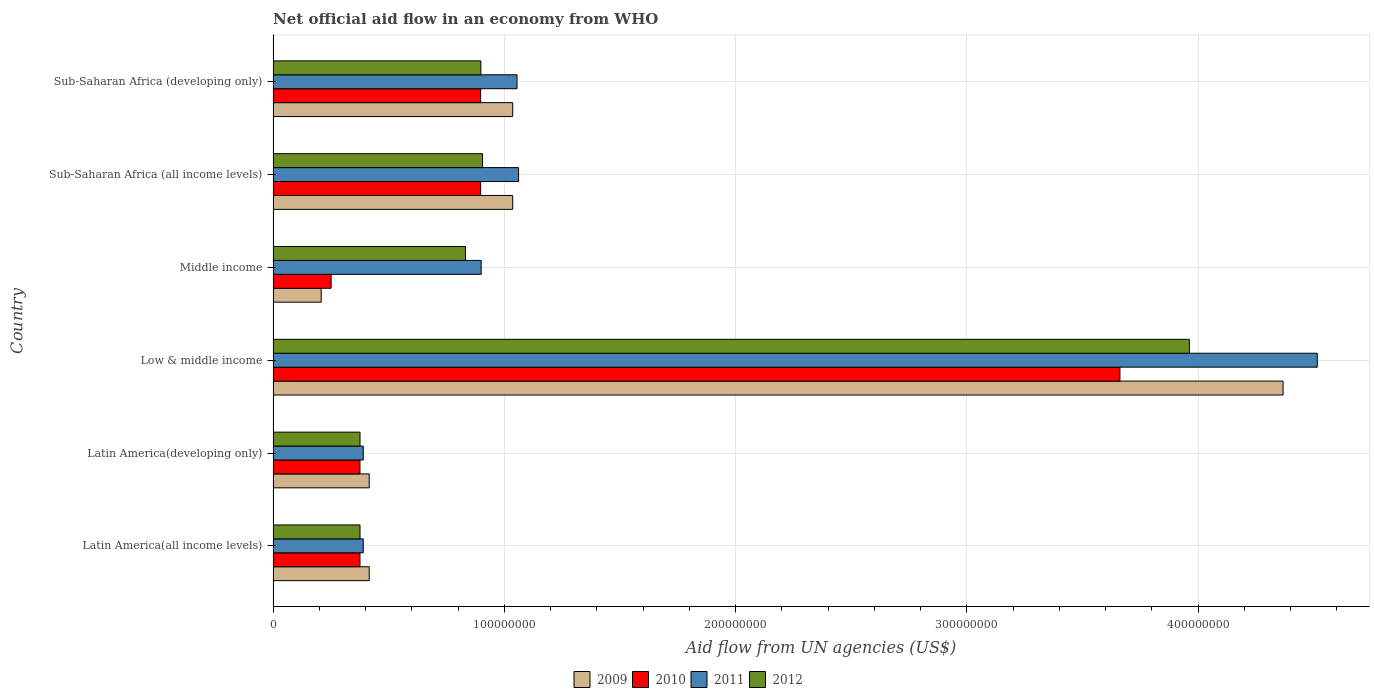How many different coloured bars are there?
Provide a succinct answer. 4. How many groups of bars are there?
Provide a succinct answer. 6. Are the number of bars per tick equal to the number of legend labels?
Provide a succinct answer. Yes. Are the number of bars on each tick of the Y-axis equal?
Provide a short and direct response. Yes. How many bars are there on the 5th tick from the top?
Ensure brevity in your answer.  4. What is the label of the 1st group of bars from the top?
Provide a short and direct response. Sub-Saharan Africa (developing only). In how many cases, is the number of bars for a given country not equal to the number of legend labels?
Your answer should be very brief. 0. What is the net official aid flow in 2010 in Middle income?
Keep it short and to the point. 2.51e+07. Across all countries, what is the maximum net official aid flow in 2011?
Your response must be concise. 4.52e+08. Across all countries, what is the minimum net official aid flow in 2011?
Ensure brevity in your answer.  3.90e+07. In which country was the net official aid flow in 2011 maximum?
Your answer should be very brief. Low & middle income. In which country was the net official aid flow in 2012 minimum?
Keep it short and to the point. Latin America(all income levels). What is the total net official aid flow in 2012 in the graph?
Give a very brief answer. 7.35e+08. What is the difference between the net official aid flow in 2012 in Middle income and that in Sub-Saharan Africa (developing only)?
Ensure brevity in your answer.  -6.67e+06. What is the difference between the net official aid flow in 2009 in Sub-Saharan Africa (all income levels) and the net official aid flow in 2011 in Low & middle income?
Your answer should be very brief. -3.48e+08. What is the average net official aid flow in 2009 per country?
Your answer should be very brief. 1.25e+08. What is the difference between the net official aid flow in 2011 and net official aid flow in 2010 in Latin America(all income levels)?
Give a very brief answer. 1.42e+06. In how many countries, is the net official aid flow in 2011 greater than 380000000 US$?
Ensure brevity in your answer.  1. What is the ratio of the net official aid flow in 2010 in Middle income to that in Sub-Saharan Africa (developing only)?
Your answer should be compact. 0.28. Is the net official aid flow in 2011 in Latin America(developing only) less than that in Sub-Saharan Africa (developing only)?
Your answer should be compact. Yes. What is the difference between the highest and the second highest net official aid flow in 2012?
Keep it short and to the point. 3.06e+08. What is the difference between the highest and the lowest net official aid flow in 2012?
Ensure brevity in your answer.  3.59e+08. In how many countries, is the net official aid flow in 2012 greater than the average net official aid flow in 2012 taken over all countries?
Provide a short and direct response. 1. Is the sum of the net official aid flow in 2010 in Low & middle income and Sub-Saharan Africa (developing only) greater than the maximum net official aid flow in 2012 across all countries?
Ensure brevity in your answer.  Yes. Is it the case that in every country, the sum of the net official aid flow in 2010 and net official aid flow in 2009 is greater than the sum of net official aid flow in 2011 and net official aid flow in 2012?
Offer a terse response. No. How many bars are there?
Your response must be concise. 24. Are all the bars in the graph horizontal?
Offer a terse response. Yes. How many countries are there in the graph?
Give a very brief answer. 6. Does the graph contain any zero values?
Give a very brief answer. No. Does the graph contain grids?
Your answer should be very brief. Yes. Where does the legend appear in the graph?
Offer a very short reply. Bottom center. How many legend labels are there?
Ensure brevity in your answer.  4. What is the title of the graph?
Your answer should be compact. Net official aid flow in an economy from WHO. Does "1962" appear as one of the legend labels in the graph?
Offer a very short reply. No. What is the label or title of the X-axis?
Your answer should be compact. Aid flow from UN agencies (US$). What is the label or title of the Y-axis?
Provide a succinct answer. Country. What is the Aid flow from UN agencies (US$) in 2009 in Latin America(all income levels)?
Give a very brief answer. 4.16e+07. What is the Aid flow from UN agencies (US$) in 2010 in Latin America(all income levels)?
Offer a terse response. 3.76e+07. What is the Aid flow from UN agencies (US$) in 2011 in Latin America(all income levels)?
Offer a very short reply. 3.90e+07. What is the Aid flow from UN agencies (US$) of 2012 in Latin America(all income levels)?
Your answer should be very brief. 3.76e+07. What is the Aid flow from UN agencies (US$) in 2009 in Latin America(developing only)?
Your answer should be very brief. 4.16e+07. What is the Aid flow from UN agencies (US$) of 2010 in Latin America(developing only)?
Offer a terse response. 3.76e+07. What is the Aid flow from UN agencies (US$) in 2011 in Latin America(developing only)?
Offer a terse response. 3.90e+07. What is the Aid flow from UN agencies (US$) in 2012 in Latin America(developing only)?
Keep it short and to the point. 3.76e+07. What is the Aid flow from UN agencies (US$) of 2009 in Low & middle income?
Offer a terse response. 4.37e+08. What is the Aid flow from UN agencies (US$) of 2010 in Low & middle income?
Provide a short and direct response. 3.66e+08. What is the Aid flow from UN agencies (US$) in 2011 in Low & middle income?
Give a very brief answer. 4.52e+08. What is the Aid flow from UN agencies (US$) in 2012 in Low & middle income?
Provide a succinct answer. 3.96e+08. What is the Aid flow from UN agencies (US$) of 2009 in Middle income?
Provide a succinct answer. 2.08e+07. What is the Aid flow from UN agencies (US$) of 2010 in Middle income?
Provide a succinct answer. 2.51e+07. What is the Aid flow from UN agencies (US$) in 2011 in Middle income?
Your answer should be very brief. 9.00e+07. What is the Aid flow from UN agencies (US$) in 2012 in Middle income?
Keep it short and to the point. 8.32e+07. What is the Aid flow from UN agencies (US$) of 2009 in Sub-Saharan Africa (all income levels)?
Offer a terse response. 1.04e+08. What is the Aid flow from UN agencies (US$) of 2010 in Sub-Saharan Africa (all income levels)?
Your response must be concise. 8.98e+07. What is the Aid flow from UN agencies (US$) in 2011 in Sub-Saharan Africa (all income levels)?
Give a very brief answer. 1.06e+08. What is the Aid flow from UN agencies (US$) of 2012 in Sub-Saharan Africa (all income levels)?
Give a very brief answer. 9.06e+07. What is the Aid flow from UN agencies (US$) of 2009 in Sub-Saharan Africa (developing only)?
Provide a succinct answer. 1.04e+08. What is the Aid flow from UN agencies (US$) in 2010 in Sub-Saharan Africa (developing only)?
Your answer should be compact. 8.98e+07. What is the Aid flow from UN agencies (US$) in 2011 in Sub-Saharan Africa (developing only)?
Ensure brevity in your answer.  1.05e+08. What is the Aid flow from UN agencies (US$) of 2012 in Sub-Saharan Africa (developing only)?
Your response must be concise. 8.98e+07. Across all countries, what is the maximum Aid flow from UN agencies (US$) of 2009?
Ensure brevity in your answer.  4.37e+08. Across all countries, what is the maximum Aid flow from UN agencies (US$) of 2010?
Give a very brief answer. 3.66e+08. Across all countries, what is the maximum Aid flow from UN agencies (US$) in 2011?
Ensure brevity in your answer.  4.52e+08. Across all countries, what is the maximum Aid flow from UN agencies (US$) in 2012?
Make the answer very short. 3.96e+08. Across all countries, what is the minimum Aid flow from UN agencies (US$) in 2009?
Offer a terse response. 2.08e+07. Across all countries, what is the minimum Aid flow from UN agencies (US$) in 2010?
Give a very brief answer. 2.51e+07. Across all countries, what is the minimum Aid flow from UN agencies (US$) of 2011?
Your response must be concise. 3.90e+07. Across all countries, what is the minimum Aid flow from UN agencies (US$) of 2012?
Make the answer very short. 3.76e+07. What is the total Aid flow from UN agencies (US$) of 2009 in the graph?
Give a very brief answer. 7.48e+08. What is the total Aid flow from UN agencies (US$) of 2010 in the graph?
Provide a succinct answer. 6.46e+08. What is the total Aid flow from UN agencies (US$) of 2011 in the graph?
Ensure brevity in your answer.  8.31e+08. What is the total Aid flow from UN agencies (US$) in 2012 in the graph?
Give a very brief answer. 7.35e+08. What is the difference between the Aid flow from UN agencies (US$) in 2010 in Latin America(all income levels) and that in Latin America(developing only)?
Make the answer very short. 0. What is the difference between the Aid flow from UN agencies (US$) of 2012 in Latin America(all income levels) and that in Latin America(developing only)?
Provide a short and direct response. 0. What is the difference between the Aid flow from UN agencies (US$) of 2009 in Latin America(all income levels) and that in Low & middle income?
Offer a terse response. -3.95e+08. What is the difference between the Aid flow from UN agencies (US$) in 2010 in Latin America(all income levels) and that in Low & middle income?
Offer a very short reply. -3.29e+08. What is the difference between the Aid flow from UN agencies (US$) of 2011 in Latin America(all income levels) and that in Low & middle income?
Your answer should be compact. -4.13e+08. What is the difference between the Aid flow from UN agencies (US$) of 2012 in Latin America(all income levels) and that in Low & middle income?
Offer a very short reply. -3.59e+08. What is the difference between the Aid flow from UN agencies (US$) of 2009 in Latin America(all income levels) and that in Middle income?
Offer a terse response. 2.08e+07. What is the difference between the Aid flow from UN agencies (US$) of 2010 in Latin America(all income levels) and that in Middle income?
Your answer should be very brief. 1.25e+07. What is the difference between the Aid flow from UN agencies (US$) in 2011 in Latin America(all income levels) and that in Middle income?
Your answer should be very brief. -5.10e+07. What is the difference between the Aid flow from UN agencies (US$) in 2012 in Latin America(all income levels) and that in Middle income?
Your response must be concise. -4.56e+07. What is the difference between the Aid flow from UN agencies (US$) in 2009 in Latin America(all income levels) and that in Sub-Saharan Africa (all income levels)?
Your answer should be very brief. -6.20e+07. What is the difference between the Aid flow from UN agencies (US$) in 2010 in Latin America(all income levels) and that in Sub-Saharan Africa (all income levels)?
Your response must be concise. -5.22e+07. What is the difference between the Aid flow from UN agencies (US$) in 2011 in Latin America(all income levels) and that in Sub-Saharan Africa (all income levels)?
Ensure brevity in your answer.  -6.72e+07. What is the difference between the Aid flow from UN agencies (US$) of 2012 in Latin America(all income levels) and that in Sub-Saharan Africa (all income levels)?
Offer a terse response. -5.30e+07. What is the difference between the Aid flow from UN agencies (US$) of 2009 in Latin America(all income levels) and that in Sub-Saharan Africa (developing only)?
Provide a succinct answer. -6.20e+07. What is the difference between the Aid flow from UN agencies (US$) of 2010 in Latin America(all income levels) and that in Sub-Saharan Africa (developing only)?
Your answer should be very brief. -5.22e+07. What is the difference between the Aid flow from UN agencies (US$) in 2011 in Latin America(all income levels) and that in Sub-Saharan Africa (developing only)?
Offer a terse response. -6.65e+07. What is the difference between the Aid flow from UN agencies (US$) in 2012 in Latin America(all income levels) and that in Sub-Saharan Africa (developing only)?
Provide a short and direct response. -5.23e+07. What is the difference between the Aid flow from UN agencies (US$) in 2009 in Latin America(developing only) and that in Low & middle income?
Ensure brevity in your answer.  -3.95e+08. What is the difference between the Aid flow from UN agencies (US$) of 2010 in Latin America(developing only) and that in Low & middle income?
Give a very brief answer. -3.29e+08. What is the difference between the Aid flow from UN agencies (US$) in 2011 in Latin America(developing only) and that in Low & middle income?
Your answer should be very brief. -4.13e+08. What is the difference between the Aid flow from UN agencies (US$) in 2012 in Latin America(developing only) and that in Low & middle income?
Keep it short and to the point. -3.59e+08. What is the difference between the Aid flow from UN agencies (US$) of 2009 in Latin America(developing only) and that in Middle income?
Offer a terse response. 2.08e+07. What is the difference between the Aid flow from UN agencies (US$) in 2010 in Latin America(developing only) and that in Middle income?
Your answer should be compact. 1.25e+07. What is the difference between the Aid flow from UN agencies (US$) of 2011 in Latin America(developing only) and that in Middle income?
Ensure brevity in your answer.  -5.10e+07. What is the difference between the Aid flow from UN agencies (US$) in 2012 in Latin America(developing only) and that in Middle income?
Your answer should be very brief. -4.56e+07. What is the difference between the Aid flow from UN agencies (US$) in 2009 in Latin America(developing only) and that in Sub-Saharan Africa (all income levels)?
Provide a succinct answer. -6.20e+07. What is the difference between the Aid flow from UN agencies (US$) of 2010 in Latin America(developing only) and that in Sub-Saharan Africa (all income levels)?
Provide a short and direct response. -5.22e+07. What is the difference between the Aid flow from UN agencies (US$) of 2011 in Latin America(developing only) and that in Sub-Saharan Africa (all income levels)?
Your response must be concise. -6.72e+07. What is the difference between the Aid flow from UN agencies (US$) in 2012 in Latin America(developing only) and that in Sub-Saharan Africa (all income levels)?
Your answer should be very brief. -5.30e+07. What is the difference between the Aid flow from UN agencies (US$) in 2009 in Latin America(developing only) and that in Sub-Saharan Africa (developing only)?
Offer a very short reply. -6.20e+07. What is the difference between the Aid flow from UN agencies (US$) in 2010 in Latin America(developing only) and that in Sub-Saharan Africa (developing only)?
Make the answer very short. -5.22e+07. What is the difference between the Aid flow from UN agencies (US$) of 2011 in Latin America(developing only) and that in Sub-Saharan Africa (developing only)?
Provide a short and direct response. -6.65e+07. What is the difference between the Aid flow from UN agencies (US$) of 2012 in Latin America(developing only) and that in Sub-Saharan Africa (developing only)?
Your response must be concise. -5.23e+07. What is the difference between the Aid flow from UN agencies (US$) of 2009 in Low & middle income and that in Middle income?
Offer a very short reply. 4.16e+08. What is the difference between the Aid flow from UN agencies (US$) of 2010 in Low & middle income and that in Middle income?
Keep it short and to the point. 3.41e+08. What is the difference between the Aid flow from UN agencies (US$) in 2011 in Low & middle income and that in Middle income?
Ensure brevity in your answer.  3.62e+08. What is the difference between the Aid flow from UN agencies (US$) of 2012 in Low & middle income and that in Middle income?
Your answer should be compact. 3.13e+08. What is the difference between the Aid flow from UN agencies (US$) in 2009 in Low & middle income and that in Sub-Saharan Africa (all income levels)?
Provide a short and direct response. 3.33e+08. What is the difference between the Aid flow from UN agencies (US$) of 2010 in Low & middle income and that in Sub-Saharan Africa (all income levels)?
Offer a terse response. 2.76e+08. What is the difference between the Aid flow from UN agencies (US$) of 2011 in Low & middle income and that in Sub-Saharan Africa (all income levels)?
Offer a very short reply. 3.45e+08. What is the difference between the Aid flow from UN agencies (US$) of 2012 in Low & middle income and that in Sub-Saharan Africa (all income levels)?
Provide a succinct answer. 3.06e+08. What is the difference between the Aid flow from UN agencies (US$) of 2009 in Low & middle income and that in Sub-Saharan Africa (developing only)?
Keep it short and to the point. 3.33e+08. What is the difference between the Aid flow from UN agencies (US$) of 2010 in Low & middle income and that in Sub-Saharan Africa (developing only)?
Your answer should be compact. 2.76e+08. What is the difference between the Aid flow from UN agencies (US$) in 2011 in Low & middle income and that in Sub-Saharan Africa (developing only)?
Provide a succinct answer. 3.46e+08. What is the difference between the Aid flow from UN agencies (US$) in 2012 in Low & middle income and that in Sub-Saharan Africa (developing only)?
Your answer should be very brief. 3.06e+08. What is the difference between the Aid flow from UN agencies (US$) in 2009 in Middle income and that in Sub-Saharan Africa (all income levels)?
Your response must be concise. -8.28e+07. What is the difference between the Aid flow from UN agencies (US$) of 2010 in Middle income and that in Sub-Saharan Africa (all income levels)?
Offer a terse response. -6.47e+07. What is the difference between the Aid flow from UN agencies (US$) in 2011 in Middle income and that in Sub-Saharan Africa (all income levels)?
Keep it short and to the point. -1.62e+07. What is the difference between the Aid flow from UN agencies (US$) of 2012 in Middle income and that in Sub-Saharan Africa (all income levels)?
Your response must be concise. -7.39e+06. What is the difference between the Aid flow from UN agencies (US$) of 2009 in Middle income and that in Sub-Saharan Africa (developing only)?
Your answer should be very brief. -8.28e+07. What is the difference between the Aid flow from UN agencies (US$) of 2010 in Middle income and that in Sub-Saharan Africa (developing only)?
Ensure brevity in your answer.  -6.47e+07. What is the difference between the Aid flow from UN agencies (US$) in 2011 in Middle income and that in Sub-Saharan Africa (developing only)?
Offer a very short reply. -1.55e+07. What is the difference between the Aid flow from UN agencies (US$) in 2012 in Middle income and that in Sub-Saharan Africa (developing only)?
Make the answer very short. -6.67e+06. What is the difference between the Aid flow from UN agencies (US$) in 2011 in Sub-Saharan Africa (all income levels) and that in Sub-Saharan Africa (developing only)?
Offer a terse response. 6.70e+05. What is the difference between the Aid flow from UN agencies (US$) of 2012 in Sub-Saharan Africa (all income levels) and that in Sub-Saharan Africa (developing only)?
Your answer should be compact. 7.20e+05. What is the difference between the Aid flow from UN agencies (US$) of 2009 in Latin America(all income levels) and the Aid flow from UN agencies (US$) of 2010 in Latin America(developing only)?
Offer a very short reply. 4.01e+06. What is the difference between the Aid flow from UN agencies (US$) of 2009 in Latin America(all income levels) and the Aid flow from UN agencies (US$) of 2011 in Latin America(developing only)?
Provide a short and direct response. 2.59e+06. What is the difference between the Aid flow from UN agencies (US$) in 2009 in Latin America(all income levels) and the Aid flow from UN agencies (US$) in 2012 in Latin America(developing only)?
Provide a short and direct response. 3.99e+06. What is the difference between the Aid flow from UN agencies (US$) of 2010 in Latin America(all income levels) and the Aid flow from UN agencies (US$) of 2011 in Latin America(developing only)?
Give a very brief answer. -1.42e+06. What is the difference between the Aid flow from UN agencies (US$) of 2010 in Latin America(all income levels) and the Aid flow from UN agencies (US$) of 2012 in Latin America(developing only)?
Your response must be concise. -2.00e+04. What is the difference between the Aid flow from UN agencies (US$) of 2011 in Latin America(all income levels) and the Aid flow from UN agencies (US$) of 2012 in Latin America(developing only)?
Ensure brevity in your answer.  1.40e+06. What is the difference between the Aid flow from UN agencies (US$) of 2009 in Latin America(all income levels) and the Aid flow from UN agencies (US$) of 2010 in Low & middle income?
Provide a succinct answer. -3.25e+08. What is the difference between the Aid flow from UN agencies (US$) in 2009 in Latin America(all income levels) and the Aid flow from UN agencies (US$) in 2011 in Low & middle income?
Ensure brevity in your answer.  -4.10e+08. What is the difference between the Aid flow from UN agencies (US$) in 2009 in Latin America(all income levels) and the Aid flow from UN agencies (US$) in 2012 in Low & middle income?
Your answer should be compact. -3.55e+08. What is the difference between the Aid flow from UN agencies (US$) of 2010 in Latin America(all income levels) and the Aid flow from UN agencies (US$) of 2011 in Low & middle income?
Your answer should be compact. -4.14e+08. What is the difference between the Aid flow from UN agencies (US$) of 2010 in Latin America(all income levels) and the Aid flow from UN agencies (US$) of 2012 in Low & middle income?
Provide a short and direct response. -3.59e+08. What is the difference between the Aid flow from UN agencies (US$) in 2011 in Latin America(all income levels) and the Aid flow from UN agencies (US$) in 2012 in Low & middle income?
Provide a short and direct response. -3.57e+08. What is the difference between the Aid flow from UN agencies (US$) in 2009 in Latin America(all income levels) and the Aid flow from UN agencies (US$) in 2010 in Middle income?
Ensure brevity in your answer.  1.65e+07. What is the difference between the Aid flow from UN agencies (US$) in 2009 in Latin America(all income levels) and the Aid flow from UN agencies (US$) in 2011 in Middle income?
Your response must be concise. -4.84e+07. What is the difference between the Aid flow from UN agencies (US$) of 2009 in Latin America(all income levels) and the Aid flow from UN agencies (US$) of 2012 in Middle income?
Provide a succinct answer. -4.16e+07. What is the difference between the Aid flow from UN agencies (US$) of 2010 in Latin America(all income levels) and the Aid flow from UN agencies (US$) of 2011 in Middle income?
Keep it short and to the point. -5.24e+07. What is the difference between the Aid flow from UN agencies (US$) in 2010 in Latin America(all income levels) and the Aid flow from UN agencies (US$) in 2012 in Middle income?
Keep it short and to the point. -4.56e+07. What is the difference between the Aid flow from UN agencies (US$) in 2011 in Latin America(all income levels) and the Aid flow from UN agencies (US$) in 2012 in Middle income?
Provide a succinct answer. -4.42e+07. What is the difference between the Aid flow from UN agencies (US$) of 2009 in Latin America(all income levels) and the Aid flow from UN agencies (US$) of 2010 in Sub-Saharan Africa (all income levels)?
Offer a terse response. -4.82e+07. What is the difference between the Aid flow from UN agencies (US$) in 2009 in Latin America(all income levels) and the Aid flow from UN agencies (US$) in 2011 in Sub-Saharan Africa (all income levels)?
Your response must be concise. -6.46e+07. What is the difference between the Aid flow from UN agencies (US$) in 2009 in Latin America(all income levels) and the Aid flow from UN agencies (US$) in 2012 in Sub-Saharan Africa (all income levels)?
Offer a very short reply. -4.90e+07. What is the difference between the Aid flow from UN agencies (US$) in 2010 in Latin America(all income levels) and the Aid flow from UN agencies (US$) in 2011 in Sub-Saharan Africa (all income levels)?
Ensure brevity in your answer.  -6.86e+07. What is the difference between the Aid flow from UN agencies (US$) of 2010 in Latin America(all income levels) and the Aid flow from UN agencies (US$) of 2012 in Sub-Saharan Africa (all income levels)?
Offer a terse response. -5.30e+07. What is the difference between the Aid flow from UN agencies (US$) of 2011 in Latin America(all income levels) and the Aid flow from UN agencies (US$) of 2012 in Sub-Saharan Africa (all income levels)?
Provide a short and direct response. -5.16e+07. What is the difference between the Aid flow from UN agencies (US$) of 2009 in Latin America(all income levels) and the Aid flow from UN agencies (US$) of 2010 in Sub-Saharan Africa (developing only)?
Provide a succinct answer. -4.82e+07. What is the difference between the Aid flow from UN agencies (US$) in 2009 in Latin America(all income levels) and the Aid flow from UN agencies (US$) in 2011 in Sub-Saharan Africa (developing only)?
Ensure brevity in your answer.  -6.39e+07. What is the difference between the Aid flow from UN agencies (US$) in 2009 in Latin America(all income levels) and the Aid flow from UN agencies (US$) in 2012 in Sub-Saharan Africa (developing only)?
Offer a terse response. -4.83e+07. What is the difference between the Aid flow from UN agencies (US$) in 2010 in Latin America(all income levels) and the Aid flow from UN agencies (US$) in 2011 in Sub-Saharan Africa (developing only)?
Provide a succinct answer. -6.79e+07. What is the difference between the Aid flow from UN agencies (US$) in 2010 in Latin America(all income levels) and the Aid flow from UN agencies (US$) in 2012 in Sub-Saharan Africa (developing only)?
Give a very brief answer. -5.23e+07. What is the difference between the Aid flow from UN agencies (US$) in 2011 in Latin America(all income levels) and the Aid flow from UN agencies (US$) in 2012 in Sub-Saharan Africa (developing only)?
Offer a very short reply. -5.09e+07. What is the difference between the Aid flow from UN agencies (US$) of 2009 in Latin America(developing only) and the Aid flow from UN agencies (US$) of 2010 in Low & middle income?
Your answer should be very brief. -3.25e+08. What is the difference between the Aid flow from UN agencies (US$) in 2009 in Latin America(developing only) and the Aid flow from UN agencies (US$) in 2011 in Low & middle income?
Give a very brief answer. -4.10e+08. What is the difference between the Aid flow from UN agencies (US$) of 2009 in Latin America(developing only) and the Aid flow from UN agencies (US$) of 2012 in Low & middle income?
Provide a succinct answer. -3.55e+08. What is the difference between the Aid flow from UN agencies (US$) in 2010 in Latin America(developing only) and the Aid flow from UN agencies (US$) in 2011 in Low & middle income?
Offer a very short reply. -4.14e+08. What is the difference between the Aid flow from UN agencies (US$) in 2010 in Latin America(developing only) and the Aid flow from UN agencies (US$) in 2012 in Low & middle income?
Provide a succinct answer. -3.59e+08. What is the difference between the Aid flow from UN agencies (US$) of 2011 in Latin America(developing only) and the Aid flow from UN agencies (US$) of 2012 in Low & middle income?
Make the answer very short. -3.57e+08. What is the difference between the Aid flow from UN agencies (US$) in 2009 in Latin America(developing only) and the Aid flow from UN agencies (US$) in 2010 in Middle income?
Make the answer very short. 1.65e+07. What is the difference between the Aid flow from UN agencies (US$) of 2009 in Latin America(developing only) and the Aid flow from UN agencies (US$) of 2011 in Middle income?
Provide a succinct answer. -4.84e+07. What is the difference between the Aid flow from UN agencies (US$) in 2009 in Latin America(developing only) and the Aid flow from UN agencies (US$) in 2012 in Middle income?
Give a very brief answer. -4.16e+07. What is the difference between the Aid flow from UN agencies (US$) of 2010 in Latin America(developing only) and the Aid flow from UN agencies (US$) of 2011 in Middle income?
Your answer should be compact. -5.24e+07. What is the difference between the Aid flow from UN agencies (US$) in 2010 in Latin America(developing only) and the Aid flow from UN agencies (US$) in 2012 in Middle income?
Provide a short and direct response. -4.56e+07. What is the difference between the Aid flow from UN agencies (US$) of 2011 in Latin America(developing only) and the Aid flow from UN agencies (US$) of 2012 in Middle income?
Offer a terse response. -4.42e+07. What is the difference between the Aid flow from UN agencies (US$) in 2009 in Latin America(developing only) and the Aid flow from UN agencies (US$) in 2010 in Sub-Saharan Africa (all income levels)?
Make the answer very short. -4.82e+07. What is the difference between the Aid flow from UN agencies (US$) of 2009 in Latin America(developing only) and the Aid flow from UN agencies (US$) of 2011 in Sub-Saharan Africa (all income levels)?
Give a very brief answer. -6.46e+07. What is the difference between the Aid flow from UN agencies (US$) of 2009 in Latin America(developing only) and the Aid flow from UN agencies (US$) of 2012 in Sub-Saharan Africa (all income levels)?
Provide a short and direct response. -4.90e+07. What is the difference between the Aid flow from UN agencies (US$) of 2010 in Latin America(developing only) and the Aid flow from UN agencies (US$) of 2011 in Sub-Saharan Africa (all income levels)?
Offer a terse response. -6.86e+07. What is the difference between the Aid flow from UN agencies (US$) of 2010 in Latin America(developing only) and the Aid flow from UN agencies (US$) of 2012 in Sub-Saharan Africa (all income levels)?
Give a very brief answer. -5.30e+07. What is the difference between the Aid flow from UN agencies (US$) in 2011 in Latin America(developing only) and the Aid flow from UN agencies (US$) in 2012 in Sub-Saharan Africa (all income levels)?
Provide a short and direct response. -5.16e+07. What is the difference between the Aid flow from UN agencies (US$) of 2009 in Latin America(developing only) and the Aid flow from UN agencies (US$) of 2010 in Sub-Saharan Africa (developing only)?
Provide a succinct answer. -4.82e+07. What is the difference between the Aid flow from UN agencies (US$) in 2009 in Latin America(developing only) and the Aid flow from UN agencies (US$) in 2011 in Sub-Saharan Africa (developing only)?
Provide a succinct answer. -6.39e+07. What is the difference between the Aid flow from UN agencies (US$) of 2009 in Latin America(developing only) and the Aid flow from UN agencies (US$) of 2012 in Sub-Saharan Africa (developing only)?
Keep it short and to the point. -4.83e+07. What is the difference between the Aid flow from UN agencies (US$) of 2010 in Latin America(developing only) and the Aid flow from UN agencies (US$) of 2011 in Sub-Saharan Africa (developing only)?
Offer a very short reply. -6.79e+07. What is the difference between the Aid flow from UN agencies (US$) in 2010 in Latin America(developing only) and the Aid flow from UN agencies (US$) in 2012 in Sub-Saharan Africa (developing only)?
Your response must be concise. -5.23e+07. What is the difference between the Aid flow from UN agencies (US$) of 2011 in Latin America(developing only) and the Aid flow from UN agencies (US$) of 2012 in Sub-Saharan Africa (developing only)?
Provide a succinct answer. -5.09e+07. What is the difference between the Aid flow from UN agencies (US$) of 2009 in Low & middle income and the Aid flow from UN agencies (US$) of 2010 in Middle income?
Provide a succinct answer. 4.12e+08. What is the difference between the Aid flow from UN agencies (US$) of 2009 in Low & middle income and the Aid flow from UN agencies (US$) of 2011 in Middle income?
Give a very brief answer. 3.47e+08. What is the difference between the Aid flow from UN agencies (US$) in 2009 in Low & middle income and the Aid flow from UN agencies (US$) in 2012 in Middle income?
Give a very brief answer. 3.54e+08. What is the difference between the Aid flow from UN agencies (US$) in 2010 in Low & middle income and the Aid flow from UN agencies (US$) in 2011 in Middle income?
Provide a short and direct response. 2.76e+08. What is the difference between the Aid flow from UN agencies (US$) of 2010 in Low & middle income and the Aid flow from UN agencies (US$) of 2012 in Middle income?
Offer a very short reply. 2.83e+08. What is the difference between the Aid flow from UN agencies (US$) in 2011 in Low & middle income and the Aid flow from UN agencies (US$) in 2012 in Middle income?
Offer a very short reply. 3.68e+08. What is the difference between the Aid flow from UN agencies (US$) in 2009 in Low & middle income and the Aid flow from UN agencies (US$) in 2010 in Sub-Saharan Africa (all income levels)?
Ensure brevity in your answer.  3.47e+08. What is the difference between the Aid flow from UN agencies (US$) in 2009 in Low & middle income and the Aid flow from UN agencies (US$) in 2011 in Sub-Saharan Africa (all income levels)?
Offer a very short reply. 3.31e+08. What is the difference between the Aid flow from UN agencies (US$) in 2009 in Low & middle income and the Aid flow from UN agencies (US$) in 2012 in Sub-Saharan Africa (all income levels)?
Your answer should be compact. 3.46e+08. What is the difference between the Aid flow from UN agencies (US$) of 2010 in Low & middle income and the Aid flow from UN agencies (US$) of 2011 in Sub-Saharan Africa (all income levels)?
Give a very brief answer. 2.60e+08. What is the difference between the Aid flow from UN agencies (US$) of 2010 in Low & middle income and the Aid flow from UN agencies (US$) of 2012 in Sub-Saharan Africa (all income levels)?
Offer a very short reply. 2.76e+08. What is the difference between the Aid flow from UN agencies (US$) in 2011 in Low & middle income and the Aid flow from UN agencies (US$) in 2012 in Sub-Saharan Africa (all income levels)?
Offer a terse response. 3.61e+08. What is the difference between the Aid flow from UN agencies (US$) in 2009 in Low & middle income and the Aid flow from UN agencies (US$) in 2010 in Sub-Saharan Africa (developing only)?
Provide a succinct answer. 3.47e+08. What is the difference between the Aid flow from UN agencies (US$) of 2009 in Low & middle income and the Aid flow from UN agencies (US$) of 2011 in Sub-Saharan Africa (developing only)?
Provide a short and direct response. 3.31e+08. What is the difference between the Aid flow from UN agencies (US$) in 2009 in Low & middle income and the Aid flow from UN agencies (US$) in 2012 in Sub-Saharan Africa (developing only)?
Provide a succinct answer. 3.47e+08. What is the difference between the Aid flow from UN agencies (US$) in 2010 in Low & middle income and the Aid flow from UN agencies (US$) in 2011 in Sub-Saharan Africa (developing only)?
Provide a succinct answer. 2.61e+08. What is the difference between the Aid flow from UN agencies (US$) in 2010 in Low & middle income and the Aid flow from UN agencies (US$) in 2012 in Sub-Saharan Africa (developing only)?
Make the answer very short. 2.76e+08. What is the difference between the Aid flow from UN agencies (US$) of 2011 in Low & middle income and the Aid flow from UN agencies (US$) of 2012 in Sub-Saharan Africa (developing only)?
Provide a succinct answer. 3.62e+08. What is the difference between the Aid flow from UN agencies (US$) of 2009 in Middle income and the Aid flow from UN agencies (US$) of 2010 in Sub-Saharan Africa (all income levels)?
Ensure brevity in your answer.  -6.90e+07. What is the difference between the Aid flow from UN agencies (US$) of 2009 in Middle income and the Aid flow from UN agencies (US$) of 2011 in Sub-Saharan Africa (all income levels)?
Keep it short and to the point. -8.54e+07. What is the difference between the Aid flow from UN agencies (US$) in 2009 in Middle income and the Aid flow from UN agencies (US$) in 2012 in Sub-Saharan Africa (all income levels)?
Give a very brief answer. -6.98e+07. What is the difference between the Aid flow from UN agencies (US$) of 2010 in Middle income and the Aid flow from UN agencies (US$) of 2011 in Sub-Saharan Africa (all income levels)?
Your response must be concise. -8.11e+07. What is the difference between the Aid flow from UN agencies (US$) in 2010 in Middle income and the Aid flow from UN agencies (US$) in 2012 in Sub-Saharan Africa (all income levels)?
Make the answer very short. -6.55e+07. What is the difference between the Aid flow from UN agencies (US$) in 2011 in Middle income and the Aid flow from UN agencies (US$) in 2012 in Sub-Saharan Africa (all income levels)?
Your answer should be very brief. -5.90e+05. What is the difference between the Aid flow from UN agencies (US$) in 2009 in Middle income and the Aid flow from UN agencies (US$) in 2010 in Sub-Saharan Africa (developing only)?
Your answer should be very brief. -6.90e+07. What is the difference between the Aid flow from UN agencies (US$) of 2009 in Middle income and the Aid flow from UN agencies (US$) of 2011 in Sub-Saharan Africa (developing only)?
Your answer should be compact. -8.47e+07. What is the difference between the Aid flow from UN agencies (US$) in 2009 in Middle income and the Aid flow from UN agencies (US$) in 2012 in Sub-Saharan Africa (developing only)?
Ensure brevity in your answer.  -6.90e+07. What is the difference between the Aid flow from UN agencies (US$) of 2010 in Middle income and the Aid flow from UN agencies (US$) of 2011 in Sub-Saharan Africa (developing only)?
Give a very brief answer. -8.04e+07. What is the difference between the Aid flow from UN agencies (US$) of 2010 in Middle income and the Aid flow from UN agencies (US$) of 2012 in Sub-Saharan Africa (developing only)?
Make the answer very short. -6.48e+07. What is the difference between the Aid flow from UN agencies (US$) of 2009 in Sub-Saharan Africa (all income levels) and the Aid flow from UN agencies (US$) of 2010 in Sub-Saharan Africa (developing only)?
Offer a very short reply. 1.39e+07. What is the difference between the Aid flow from UN agencies (US$) of 2009 in Sub-Saharan Africa (all income levels) and the Aid flow from UN agencies (US$) of 2011 in Sub-Saharan Africa (developing only)?
Provide a succinct answer. -1.86e+06. What is the difference between the Aid flow from UN agencies (US$) of 2009 in Sub-Saharan Africa (all income levels) and the Aid flow from UN agencies (US$) of 2012 in Sub-Saharan Africa (developing only)?
Your response must be concise. 1.38e+07. What is the difference between the Aid flow from UN agencies (US$) of 2010 in Sub-Saharan Africa (all income levels) and the Aid flow from UN agencies (US$) of 2011 in Sub-Saharan Africa (developing only)?
Provide a succinct answer. -1.57e+07. What is the difference between the Aid flow from UN agencies (US$) in 2010 in Sub-Saharan Africa (all income levels) and the Aid flow from UN agencies (US$) in 2012 in Sub-Saharan Africa (developing only)?
Offer a very short reply. -9.00e+04. What is the difference between the Aid flow from UN agencies (US$) in 2011 in Sub-Saharan Africa (all income levels) and the Aid flow from UN agencies (US$) in 2012 in Sub-Saharan Africa (developing only)?
Give a very brief answer. 1.63e+07. What is the average Aid flow from UN agencies (US$) in 2009 per country?
Your answer should be very brief. 1.25e+08. What is the average Aid flow from UN agencies (US$) of 2010 per country?
Offer a terse response. 1.08e+08. What is the average Aid flow from UN agencies (US$) in 2011 per country?
Make the answer very short. 1.39e+08. What is the average Aid flow from UN agencies (US$) in 2012 per country?
Your answer should be compact. 1.23e+08. What is the difference between the Aid flow from UN agencies (US$) in 2009 and Aid flow from UN agencies (US$) in 2010 in Latin America(all income levels)?
Provide a short and direct response. 4.01e+06. What is the difference between the Aid flow from UN agencies (US$) in 2009 and Aid flow from UN agencies (US$) in 2011 in Latin America(all income levels)?
Your answer should be very brief. 2.59e+06. What is the difference between the Aid flow from UN agencies (US$) in 2009 and Aid flow from UN agencies (US$) in 2012 in Latin America(all income levels)?
Your response must be concise. 3.99e+06. What is the difference between the Aid flow from UN agencies (US$) in 2010 and Aid flow from UN agencies (US$) in 2011 in Latin America(all income levels)?
Give a very brief answer. -1.42e+06. What is the difference between the Aid flow from UN agencies (US$) of 2010 and Aid flow from UN agencies (US$) of 2012 in Latin America(all income levels)?
Keep it short and to the point. -2.00e+04. What is the difference between the Aid flow from UN agencies (US$) in 2011 and Aid flow from UN agencies (US$) in 2012 in Latin America(all income levels)?
Offer a very short reply. 1.40e+06. What is the difference between the Aid flow from UN agencies (US$) of 2009 and Aid flow from UN agencies (US$) of 2010 in Latin America(developing only)?
Give a very brief answer. 4.01e+06. What is the difference between the Aid flow from UN agencies (US$) in 2009 and Aid flow from UN agencies (US$) in 2011 in Latin America(developing only)?
Make the answer very short. 2.59e+06. What is the difference between the Aid flow from UN agencies (US$) of 2009 and Aid flow from UN agencies (US$) of 2012 in Latin America(developing only)?
Keep it short and to the point. 3.99e+06. What is the difference between the Aid flow from UN agencies (US$) of 2010 and Aid flow from UN agencies (US$) of 2011 in Latin America(developing only)?
Your answer should be compact. -1.42e+06. What is the difference between the Aid flow from UN agencies (US$) of 2011 and Aid flow from UN agencies (US$) of 2012 in Latin America(developing only)?
Make the answer very short. 1.40e+06. What is the difference between the Aid flow from UN agencies (US$) in 2009 and Aid flow from UN agencies (US$) in 2010 in Low & middle income?
Provide a short and direct response. 7.06e+07. What is the difference between the Aid flow from UN agencies (US$) in 2009 and Aid flow from UN agencies (US$) in 2011 in Low & middle income?
Offer a very short reply. -1.48e+07. What is the difference between the Aid flow from UN agencies (US$) in 2009 and Aid flow from UN agencies (US$) in 2012 in Low & middle income?
Give a very brief answer. 4.05e+07. What is the difference between the Aid flow from UN agencies (US$) in 2010 and Aid flow from UN agencies (US$) in 2011 in Low & middle income?
Make the answer very short. -8.54e+07. What is the difference between the Aid flow from UN agencies (US$) in 2010 and Aid flow from UN agencies (US$) in 2012 in Low & middle income?
Your answer should be compact. -3.00e+07. What is the difference between the Aid flow from UN agencies (US$) of 2011 and Aid flow from UN agencies (US$) of 2012 in Low & middle income?
Provide a short and direct response. 5.53e+07. What is the difference between the Aid flow from UN agencies (US$) in 2009 and Aid flow from UN agencies (US$) in 2010 in Middle income?
Your response must be concise. -4.27e+06. What is the difference between the Aid flow from UN agencies (US$) of 2009 and Aid flow from UN agencies (US$) of 2011 in Middle income?
Your answer should be compact. -6.92e+07. What is the difference between the Aid flow from UN agencies (US$) in 2009 and Aid flow from UN agencies (US$) in 2012 in Middle income?
Your response must be concise. -6.24e+07. What is the difference between the Aid flow from UN agencies (US$) of 2010 and Aid flow from UN agencies (US$) of 2011 in Middle income?
Provide a short and direct response. -6.49e+07. What is the difference between the Aid flow from UN agencies (US$) in 2010 and Aid flow from UN agencies (US$) in 2012 in Middle income?
Your answer should be very brief. -5.81e+07. What is the difference between the Aid flow from UN agencies (US$) of 2011 and Aid flow from UN agencies (US$) of 2012 in Middle income?
Ensure brevity in your answer.  6.80e+06. What is the difference between the Aid flow from UN agencies (US$) of 2009 and Aid flow from UN agencies (US$) of 2010 in Sub-Saharan Africa (all income levels)?
Ensure brevity in your answer.  1.39e+07. What is the difference between the Aid flow from UN agencies (US$) in 2009 and Aid flow from UN agencies (US$) in 2011 in Sub-Saharan Africa (all income levels)?
Your response must be concise. -2.53e+06. What is the difference between the Aid flow from UN agencies (US$) in 2009 and Aid flow from UN agencies (US$) in 2012 in Sub-Saharan Africa (all income levels)?
Ensure brevity in your answer.  1.30e+07. What is the difference between the Aid flow from UN agencies (US$) in 2010 and Aid flow from UN agencies (US$) in 2011 in Sub-Saharan Africa (all income levels)?
Your answer should be compact. -1.64e+07. What is the difference between the Aid flow from UN agencies (US$) in 2010 and Aid flow from UN agencies (US$) in 2012 in Sub-Saharan Africa (all income levels)?
Your response must be concise. -8.10e+05. What is the difference between the Aid flow from UN agencies (US$) of 2011 and Aid flow from UN agencies (US$) of 2012 in Sub-Saharan Africa (all income levels)?
Keep it short and to the point. 1.56e+07. What is the difference between the Aid flow from UN agencies (US$) of 2009 and Aid flow from UN agencies (US$) of 2010 in Sub-Saharan Africa (developing only)?
Ensure brevity in your answer.  1.39e+07. What is the difference between the Aid flow from UN agencies (US$) in 2009 and Aid flow from UN agencies (US$) in 2011 in Sub-Saharan Africa (developing only)?
Keep it short and to the point. -1.86e+06. What is the difference between the Aid flow from UN agencies (US$) in 2009 and Aid flow from UN agencies (US$) in 2012 in Sub-Saharan Africa (developing only)?
Give a very brief answer. 1.38e+07. What is the difference between the Aid flow from UN agencies (US$) in 2010 and Aid flow from UN agencies (US$) in 2011 in Sub-Saharan Africa (developing only)?
Offer a very short reply. -1.57e+07. What is the difference between the Aid flow from UN agencies (US$) in 2011 and Aid flow from UN agencies (US$) in 2012 in Sub-Saharan Africa (developing only)?
Provide a short and direct response. 1.56e+07. What is the ratio of the Aid flow from UN agencies (US$) in 2009 in Latin America(all income levels) to that in Latin America(developing only)?
Your answer should be very brief. 1. What is the ratio of the Aid flow from UN agencies (US$) of 2012 in Latin America(all income levels) to that in Latin America(developing only)?
Keep it short and to the point. 1. What is the ratio of the Aid flow from UN agencies (US$) of 2009 in Latin America(all income levels) to that in Low & middle income?
Offer a terse response. 0.1. What is the ratio of the Aid flow from UN agencies (US$) in 2010 in Latin America(all income levels) to that in Low & middle income?
Offer a very short reply. 0.1. What is the ratio of the Aid flow from UN agencies (US$) of 2011 in Latin America(all income levels) to that in Low & middle income?
Offer a terse response. 0.09. What is the ratio of the Aid flow from UN agencies (US$) of 2012 in Latin America(all income levels) to that in Low & middle income?
Offer a very short reply. 0.09. What is the ratio of the Aid flow from UN agencies (US$) in 2009 in Latin America(all income levels) to that in Middle income?
Offer a terse response. 2. What is the ratio of the Aid flow from UN agencies (US$) of 2010 in Latin America(all income levels) to that in Middle income?
Provide a short and direct response. 1.5. What is the ratio of the Aid flow from UN agencies (US$) in 2011 in Latin America(all income levels) to that in Middle income?
Offer a terse response. 0.43. What is the ratio of the Aid flow from UN agencies (US$) in 2012 in Latin America(all income levels) to that in Middle income?
Make the answer very short. 0.45. What is the ratio of the Aid flow from UN agencies (US$) of 2009 in Latin America(all income levels) to that in Sub-Saharan Africa (all income levels)?
Give a very brief answer. 0.4. What is the ratio of the Aid flow from UN agencies (US$) of 2010 in Latin America(all income levels) to that in Sub-Saharan Africa (all income levels)?
Keep it short and to the point. 0.42. What is the ratio of the Aid flow from UN agencies (US$) in 2011 in Latin America(all income levels) to that in Sub-Saharan Africa (all income levels)?
Ensure brevity in your answer.  0.37. What is the ratio of the Aid flow from UN agencies (US$) in 2012 in Latin America(all income levels) to that in Sub-Saharan Africa (all income levels)?
Your answer should be very brief. 0.41. What is the ratio of the Aid flow from UN agencies (US$) of 2009 in Latin America(all income levels) to that in Sub-Saharan Africa (developing only)?
Give a very brief answer. 0.4. What is the ratio of the Aid flow from UN agencies (US$) of 2010 in Latin America(all income levels) to that in Sub-Saharan Africa (developing only)?
Make the answer very short. 0.42. What is the ratio of the Aid flow from UN agencies (US$) of 2011 in Latin America(all income levels) to that in Sub-Saharan Africa (developing only)?
Your answer should be compact. 0.37. What is the ratio of the Aid flow from UN agencies (US$) of 2012 in Latin America(all income levels) to that in Sub-Saharan Africa (developing only)?
Give a very brief answer. 0.42. What is the ratio of the Aid flow from UN agencies (US$) in 2009 in Latin America(developing only) to that in Low & middle income?
Make the answer very short. 0.1. What is the ratio of the Aid flow from UN agencies (US$) of 2010 in Latin America(developing only) to that in Low & middle income?
Give a very brief answer. 0.1. What is the ratio of the Aid flow from UN agencies (US$) in 2011 in Latin America(developing only) to that in Low & middle income?
Provide a succinct answer. 0.09. What is the ratio of the Aid flow from UN agencies (US$) in 2012 in Latin America(developing only) to that in Low & middle income?
Your response must be concise. 0.09. What is the ratio of the Aid flow from UN agencies (US$) in 2009 in Latin America(developing only) to that in Middle income?
Your answer should be compact. 2. What is the ratio of the Aid flow from UN agencies (US$) in 2010 in Latin America(developing only) to that in Middle income?
Keep it short and to the point. 1.5. What is the ratio of the Aid flow from UN agencies (US$) of 2011 in Latin America(developing only) to that in Middle income?
Offer a terse response. 0.43. What is the ratio of the Aid flow from UN agencies (US$) in 2012 in Latin America(developing only) to that in Middle income?
Provide a succinct answer. 0.45. What is the ratio of the Aid flow from UN agencies (US$) of 2009 in Latin America(developing only) to that in Sub-Saharan Africa (all income levels)?
Your answer should be compact. 0.4. What is the ratio of the Aid flow from UN agencies (US$) of 2010 in Latin America(developing only) to that in Sub-Saharan Africa (all income levels)?
Offer a very short reply. 0.42. What is the ratio of the Aid flow from UN agencies (US$) of 2011 in Latin America(developing only) to that in Sub-Saharan Africa (all income levels)?
Your answer should be compact. 0.37. What is the ratio of the Aid flow from UN agencies (US$) in 2012 in Latin America(developing only) to that in Sub-Saharan Africa (all income levels)?
Provide a succinct answer. 0.41. What is the ratio of the Aid flow from UN agencies (US$) in 2009 in Latin America(developing only) to that in Sub-Saharan Africa (developing only)?
Your answer should be compact. 0.4. What is the ratio of the Aid flow from UN agencies (US$) in 2010 in Latin America(developing only) to that in Sub-Saharan Africa (developing only)?
Make the answer very short. 0.42. What is the ratio of the Aid flow from UN agencies (US$) of 2011 in Latin America(developing only) to that in Sub-Saharan Africa (developing only)?
Your answer should be compact. 0.37. What is the ratio of the Aid flow from UN agencies (US$) of 2012 in Latin America(developing only) to that in Sub-Saharan Africa (developing only)?
Ensure brevity in your answer.  0.42. What is the ratio of the Aid flow from UN agencies (US$) in 2009 in Low & middle income to that in Middle income?
Give a very brief answer. 21. What is the ratio of the Aid flow from UN agencies (US$) of 2010 in Low & middle income to that in Middle income?
Offer a terse response. 14.61. What is the ratio of the Aid flow from UN agencies (US$) in 2011 in Low & middle income to that in Middle income?
Offer a terse response. 5.02. What is the ratio of the Aid flow from UN agencies (US$) of 2012 in Low & middle income to that in Middle income?
Offer a terse response. 4.76. What is the ratio of the Aid flow from UN agencies (US$) in 2009 in Low & middle income to that in Sub-Saharan Africa (all income levels)?
Provide a short and direct response. 4.22. What is the ratio of the Aid flow from UN agencies (US$) of 2010 in Low & middle income to that in Sub-Saharan Africa (all income levels)?
Make the answer very short. 4.08. What is the ratio of the Aid flow from UN agencies (US$) of 2011 in Low & middle income to that in Sub-Saharan Africa (all income levels)?
Provide a succinct answer. 4.25. What is the ratio of the Aid flow from UN agencies (US$) in 2012 in Low & middle income to that in Sub-Saharan Africa (all income levels)?
Your response must be concise. 4.38. What is the ratio of the Aid flow from UN agencies (US$) in 2009 in Low & middle income to that in Sub-Saharan Africa (developing only)?
Offer a terse response. 4.22. What is the ratio of the Aid flow from UN agencies (US$) in 2010 in Low & middle income to that in Sub-Saharan Africa (developing only)?
Ensure brevity in your answer.  4.08. What is the ratio of the Aid flow from UN agencies (US$) of 2011 in Low & middle income to that in Sub-Saharan Africa (developing only)?
Give a very brief answer. 4.28. What is the ratio of the Aid flow from UN agencies (US$) in 2012 in Low & middle income to that in Sub-Saharan Africa (developing only)?
Ensure brevity in your answer.  4.41. What is the ratio of the Aid flow from UN agencies (US$) of 2009 in Middle income to that in Sub-Saharan Africa (all income levels)?
Provide a short and direct response. 0.2. What is the ratio of the Aid flow from UN agencies (US$) of 2010 in Middle income to that in Sub-Saharan Africa (all income levels)?
Give a very brief answer. 0.28. What is the ratio of the Aid flow from UN agencies (US$) of 2011 in Middle income to that in Sub-Saharan Africa (all income levels)?
Offer a terse response. 0.85. What is the ratio of the Aid flow from UN agencies (US$) of 2012 in Middle income to that in Sub-Saharan Africa (all income levels)?
Make the answer very short. 0.92. What is the ratio of the Aid flow from UN agencies (US$) of 2009 in Middle income to that in Sub-Saharan Africa (developing only)?
Offer a terse response. 0.2. What is the ratio of the Aid flow from UN agencies (US$) in 2010 in Middle income to that in Sub-Saharan Africa (developing only)?
Give a very brief answer. 0.28. What is the ratio of the Aid flow from UN agencies (US$) of 2011 in Middle income to that in Sub-Saharan Africa (developing only)?
Ensure brevity in your answer.  0.85. What is the ratio of the Aid flow from UN agencies (US$) of 2012 in Middle income to that in Sub-Saharan Africa (developing only)?
Your answer should be very brief. 0.93. What is the ratio of the Aid flow from UN agencies (US$) in 2011 in Sub-Saharan Africa (all income levels) to that in Sub-Saharan Africa (developing only)?
Your answer should be very brief. 1.01. What is the difference between the highest and the second highest Aid flow from UN agencies (US$) of 2009?
Keep it short and to the point. 3.33e+08. What is the difference between the highest and the second highest Aid flow from UN agencies (US$) of 2010?
Provide a short and direct response. 2.76e+08. What is the difference between the highest and the second highest Aid flow from UN agencies (US$) in 2011?
Offer a terse response. 3.45e+08. What is the difference between the highest and the second highest Aid flow from UN agencies (US$) in 2012?
Offer a very short reply. 3.06e+08. What is the difference between the highest and the lowest Aid flow from UN agencies (US$) in 2009?
Provide a succinct answer. 4.16e+08. What is the difference between the highest and the lowest Aid flow from UN agencies (US$) of 2010?
Provide a short and direct response. 3.41e+08. What is the difference between the highest and the lowest Aid flow from UN agencies (US$) in 2011?
Give a very brief answer. 4.13e+08. What is the difference between the highest and the lowest Aid flow from UN agencies (US$) of 2012?
Keep it short and to the point. 3.59e+08. 